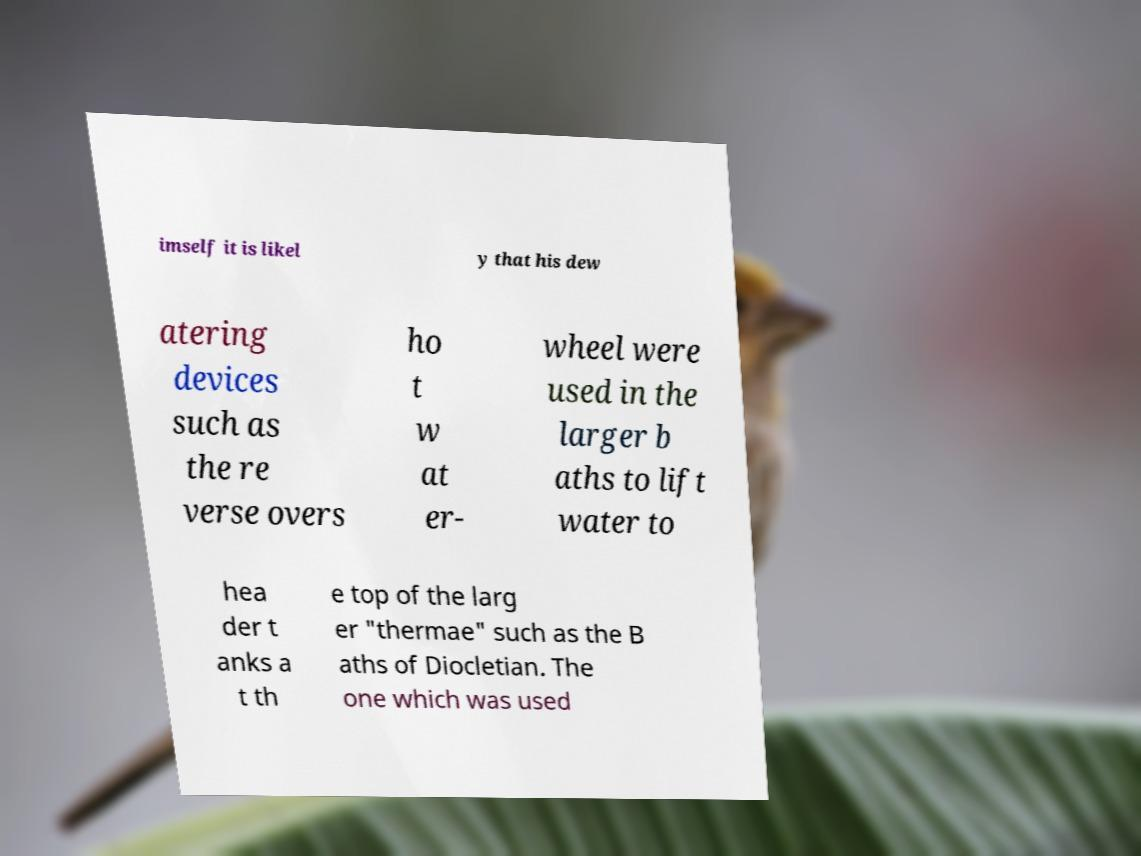Can you read and provide the text displayed in the image?This photo seems to have some interesting text. Can you extract and type it out for me? imself it is likel y that his dew atering devices such as the re verse overs ho t w at er- wheel were used in the larger b aths to lift water to hea der t anks a t th e top of the larg er "thermae" such as the B aths of Diocletian. The one which was used 